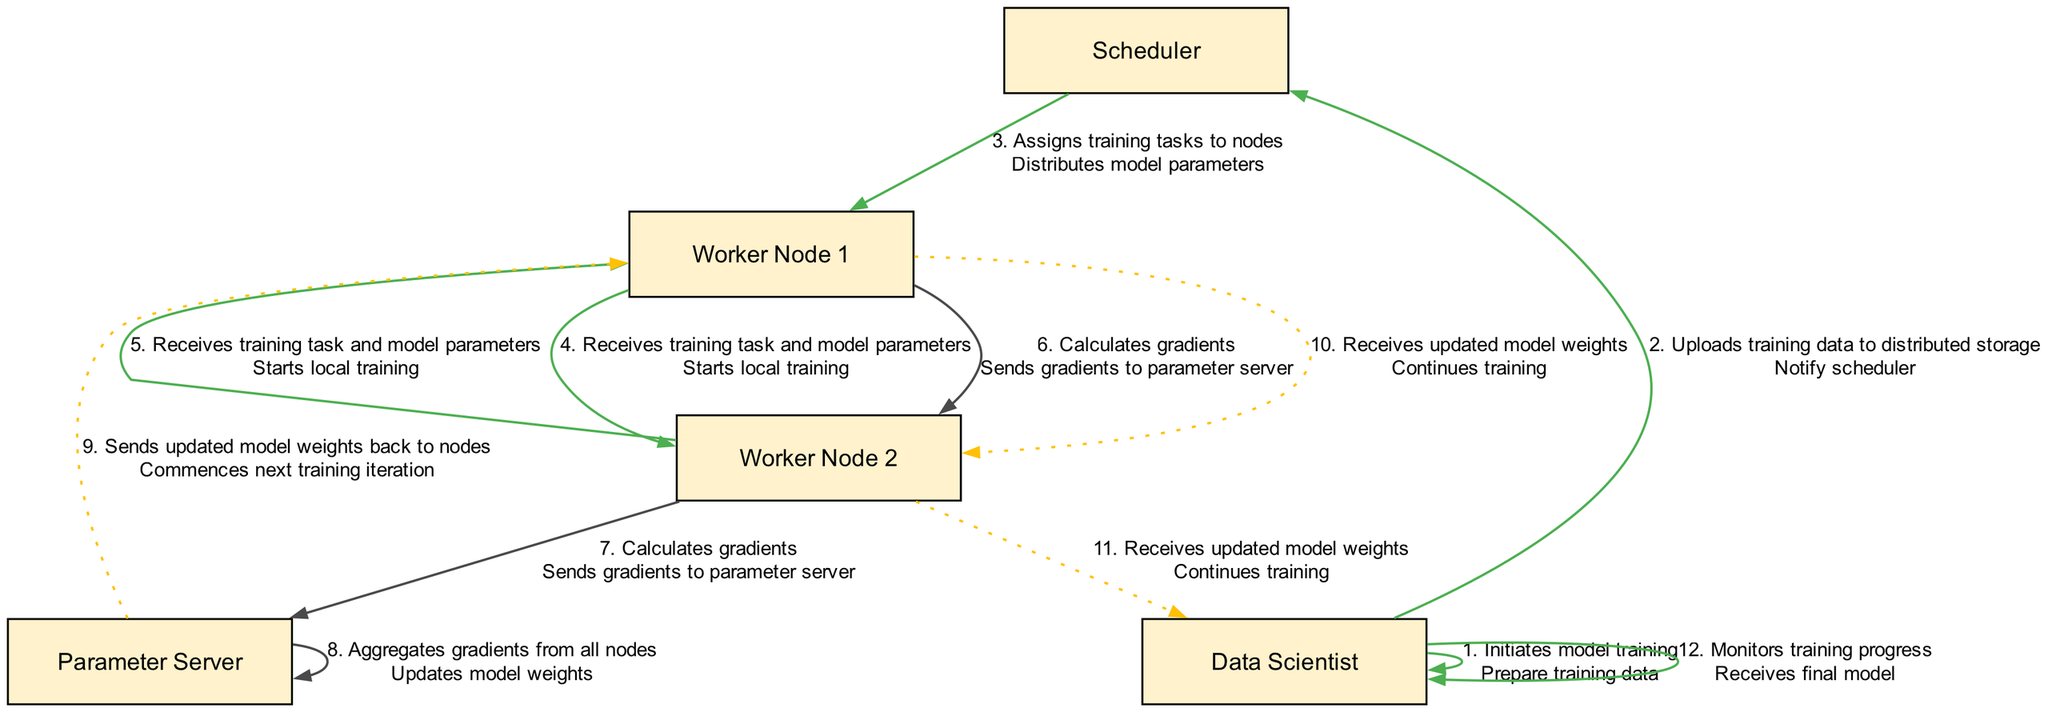What action does the Data Scientist perform first? The sequence starts with the Data Scientist, who initiates model training. This is the first action listed in the diagram.
Answer: Initiates model training How many worker nodes are involved in the training session? The diagram indicates two worker nodes, Worker Node 1 and Worker Node 2, both actively involved in the training process.
Answer: Two What is the action taken by the Parameter Server after receiving gradients? The Parameter Server aggregates gradients from all nodes, which is the immediate next action after collecting the gradients.
Answer: Aggregates gradients What do the worker nodes do with the updated model weights? Upon receiving the updated model weights from the Parameter Server, both worker nodes continue their training. This indicates they utilize the updated weights during their local training processes.
Answer: Continues training Which actor monitors the training progress? The Data Scientist is responsible for monitoring training progress in the final steps of the sequence. This identifies who tracks the efficiency and outcomes of the training session.
Answer: Data Scientist What is the total number of actions depicted in the diagram? Counting the actions listed sequentially from initiation to progress monitoring totals eleven distinct actions, encompassing each step within the training session.
Answer: Eleven What type of relationship exists between Worker Node 1 and the Parameter Server during gradient calculation? The relationship is direct; Worker Node 1 sends gradients to the Parameter Server after calculating them, outlining a clear interaction between these two entities in the training process.
Answer: Sends gradients What does the Scheduler do after the Data Scientist notifies it? Following the notification, the Scheduler assigns training tasks to the nodes, highlighting its role in delegating tasks to the worker nodes for the training process.
Answer: Assigns training tasks to nodes 